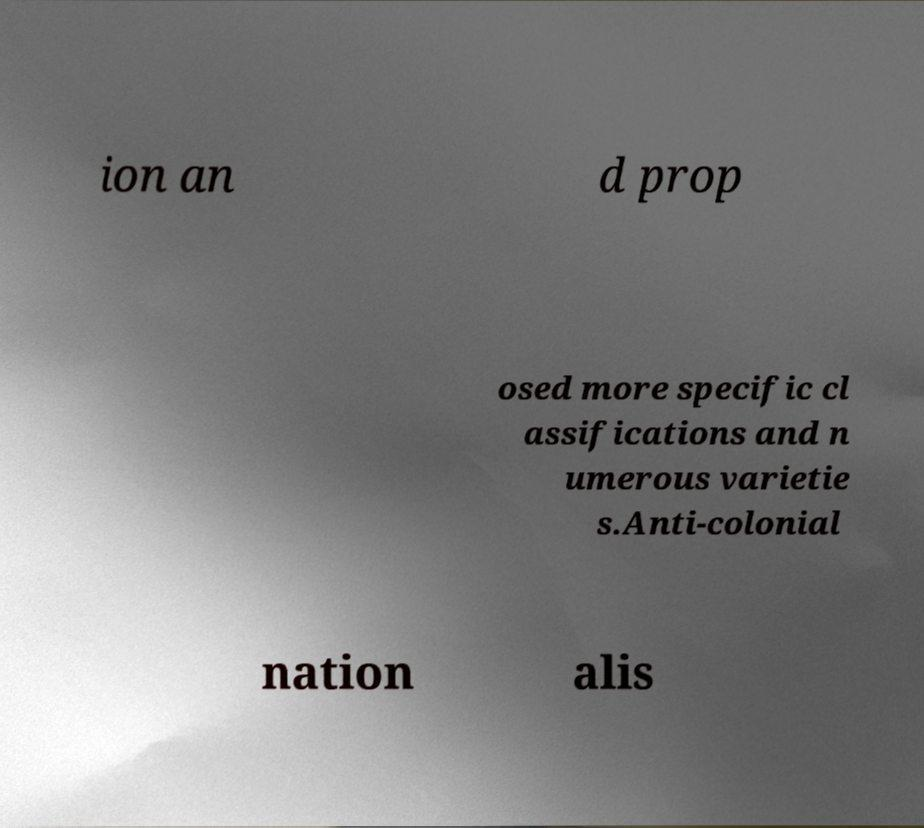Could you extract and type out the text from this image? ion an d prop osed more specific cl assifications and n umerous varietie s.Anti-colonial nation alis 